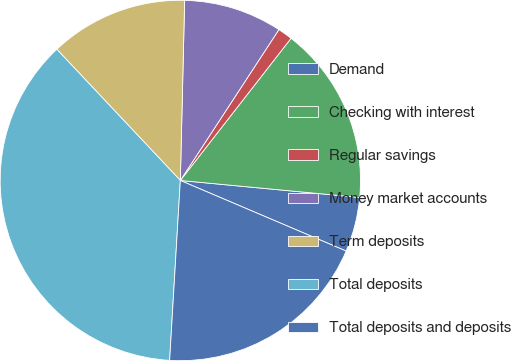Convert chart to OTSL. <chart><loc_0><loc_0><loc_500><loc_500><pie_chart><fcel>Demand<fcel>Checking with interest<fcel>Regular savings<fcel>Money market accounts<fcel>Term deposits<fcel>Total deposits<fcel>Total deposits and deposits<nl><fcel>4.9%<fcel>15.97%<fcel>1.32%<fcel>8.83%<fcel>12.4%<fcel>37.03%<fcel>19.54%<nl></chart> 